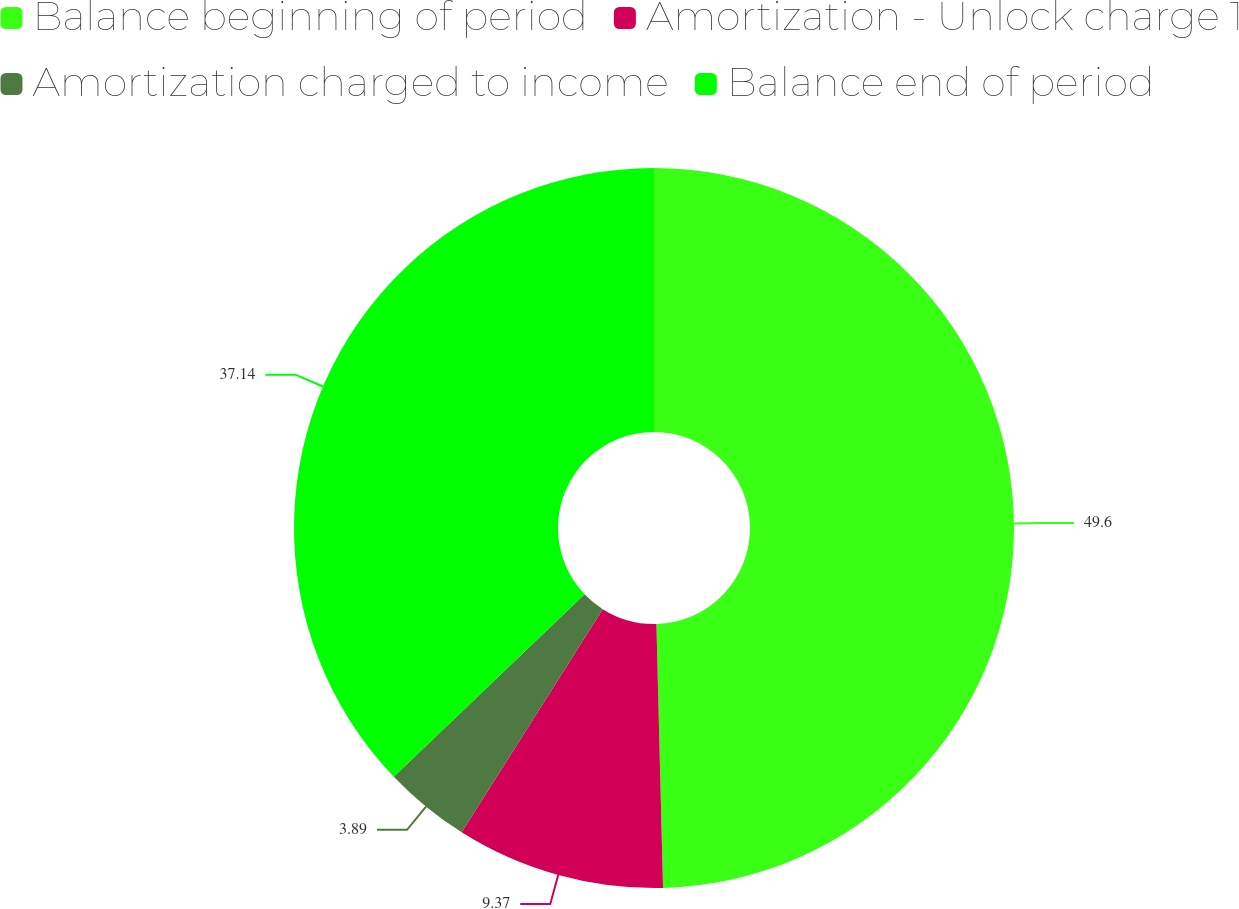Convert chart to OTSL. <chart><loc_0><loc_0><loc_500><loc_500><pie_chart><fcel>Balance beginning of period<fcel>Amortization - Unlock charge 1<fcel>Amortization charged to income<fcel>Balance end of period<nl><fcel>49.6%<fcel>9.37%<fcel>3.89%<fcel>37.14%<nl></chart> 